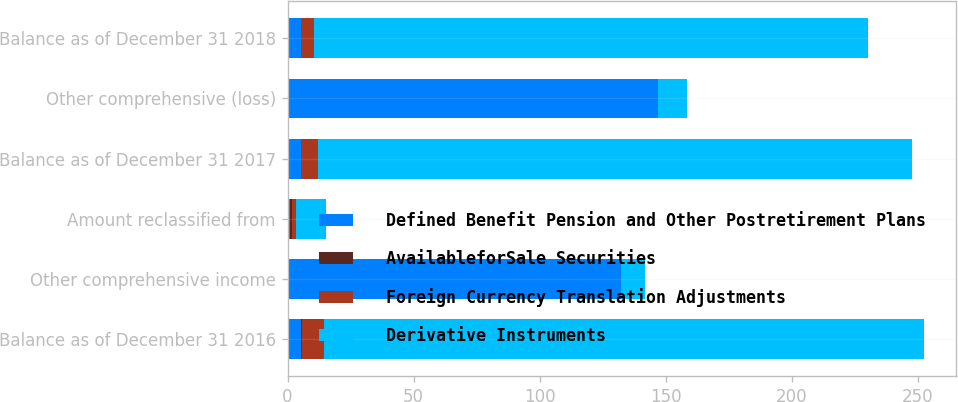Convert chart to OTSL. <chart><loc_0><loc_0><loc_500><loc_500><stacked_bar_chart><ecel><fcel>Balance as of December 31 2016<fcel>Other comprehensive income<fcel>Amount reclassified from<fcel>Balance as of December 31 2017<fcel>Other comprehensive (loss)<fcel>Balance as of December 31 2018<nl><fcel>Defined Benefit Pension and Other Postretirement Plans<fcel>5.3<fcel>132.2<fcel>1.1<fcel>5.3<fcel>146.8<fcel>5.3<nl><fcel>AvailableforSale Securities<fcel>0.6<fcel>0<fcel>0.6<fcel>0<fcel>0<fcel>0<nl><fcel>Foreign Currency Translation Adjustments<fcel>8.4<fcel>0<fcel>1.6<fcel>6.8<fcel>0<fcel>5.3<nl><fcel>Derivative Instruments<fcel>238<fcel>9.7<fcel>12<fcel>235.7<fcel>11.4<fcel>219.4<nl></chart> 